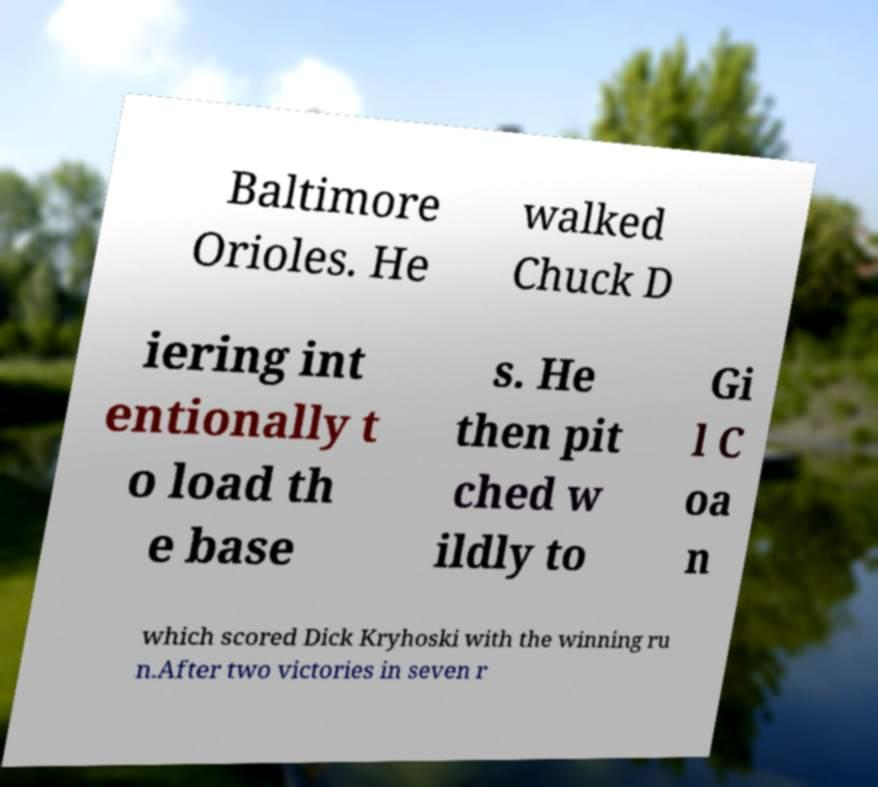Can you read and provide the text displayed in the image?This photo seems to have some interesting text. Can you extract and type it out for me? Baltimore Orioles. He walked Chuck D iering int entionally t o load th e base s. He then pit ched w ildly to Gi l C oa n which scored Dick Kryhoski with the winning ru n.After two victories in seven r 